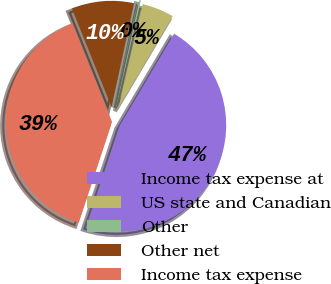Convert chart. <chart><loc_0><loc_0><loc_500><loc_500><pie_chart><fcel>Income tax expense at<fcel>US state and Canadian<fcel>Other<fcel>Other net<fcel>Income tax expense<nl><fcel>46.58%<fcel>4.87%<fcel>0.23%<fcel>9.5%<fcel>38.82%<nl></chart> 